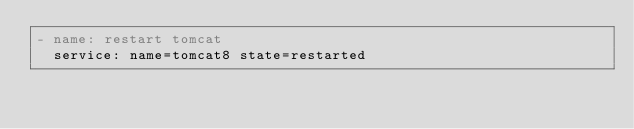<code> <loc_0><loc_0><loc_500><loc_500><_YAML_>- name: restart tomcat 
  service: name=tomcat8 state=restarted
</code> 